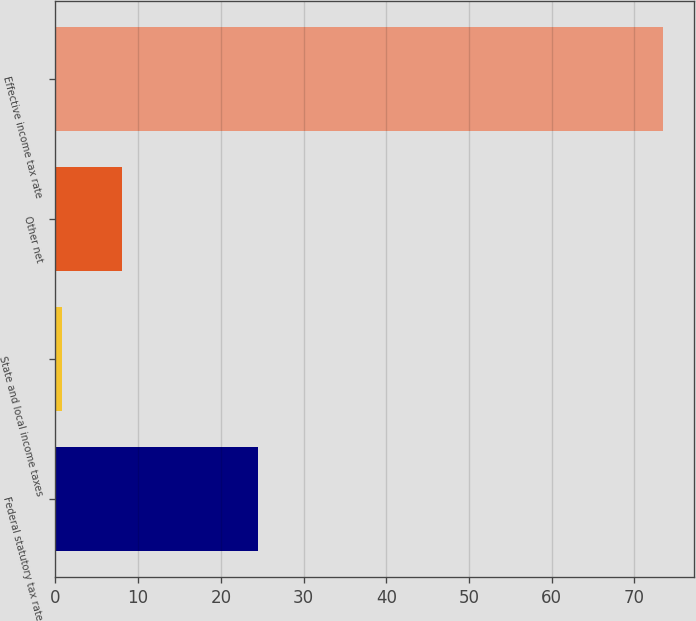<chart> <loc_0><loc_0><loc_500><loc_500><bar_chart><fcel>Federal statutory tax rate<fcel>State and local income taxes<fcel>Other net<fcel>Effective income tax rate<nl><fcel>24.5<fcel>0.8<fcel>8.07<fcel>73.5<nl></chart> 